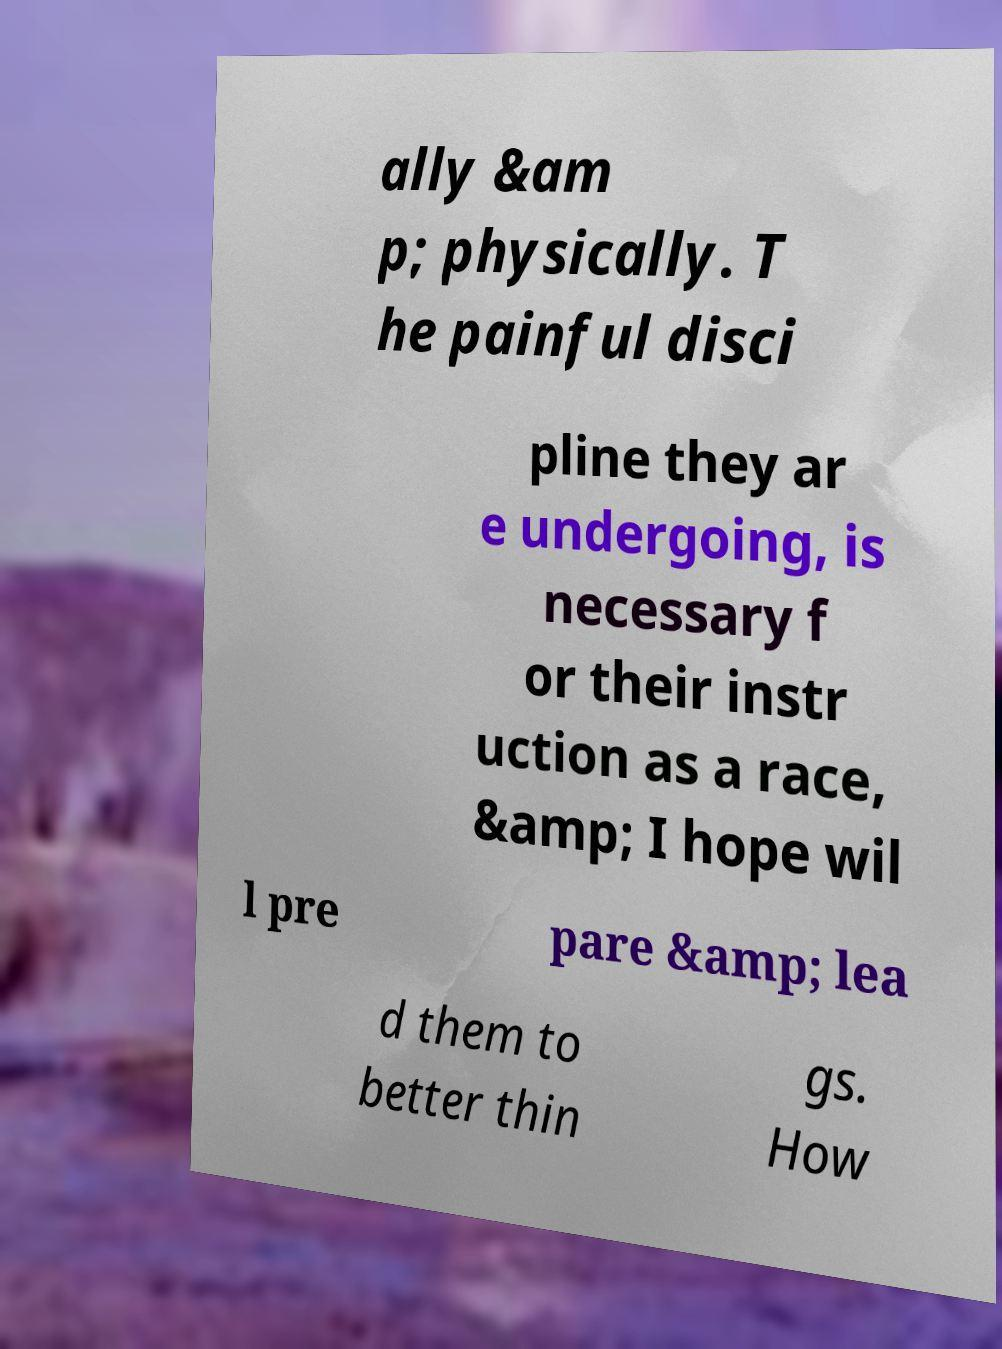There's text embedded in this image that I need extracted. Can you transcribe it verbatim? ally &am p; physically. T he painful disci pline they ar e undergoing, is necessary f or their instr uction as a race, &amp; I hope wil l pre pare &amp; lea d them to better thin gs. How 